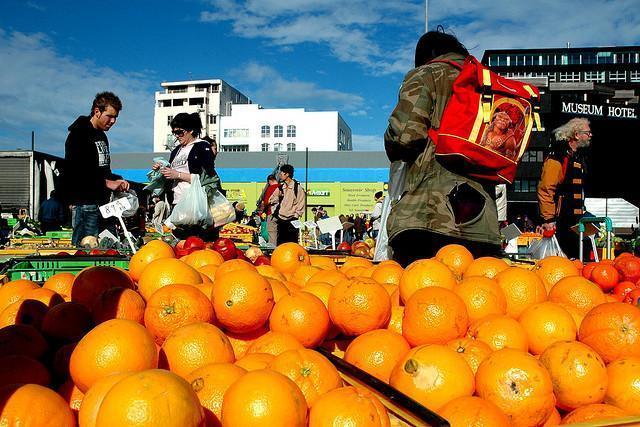How many oranges are visible?
Give a very brief answer. 6. How many people are in the photo?
Give a very brief answer. 4. How many umbrellas are there?
Give a very brief answer. 0. 